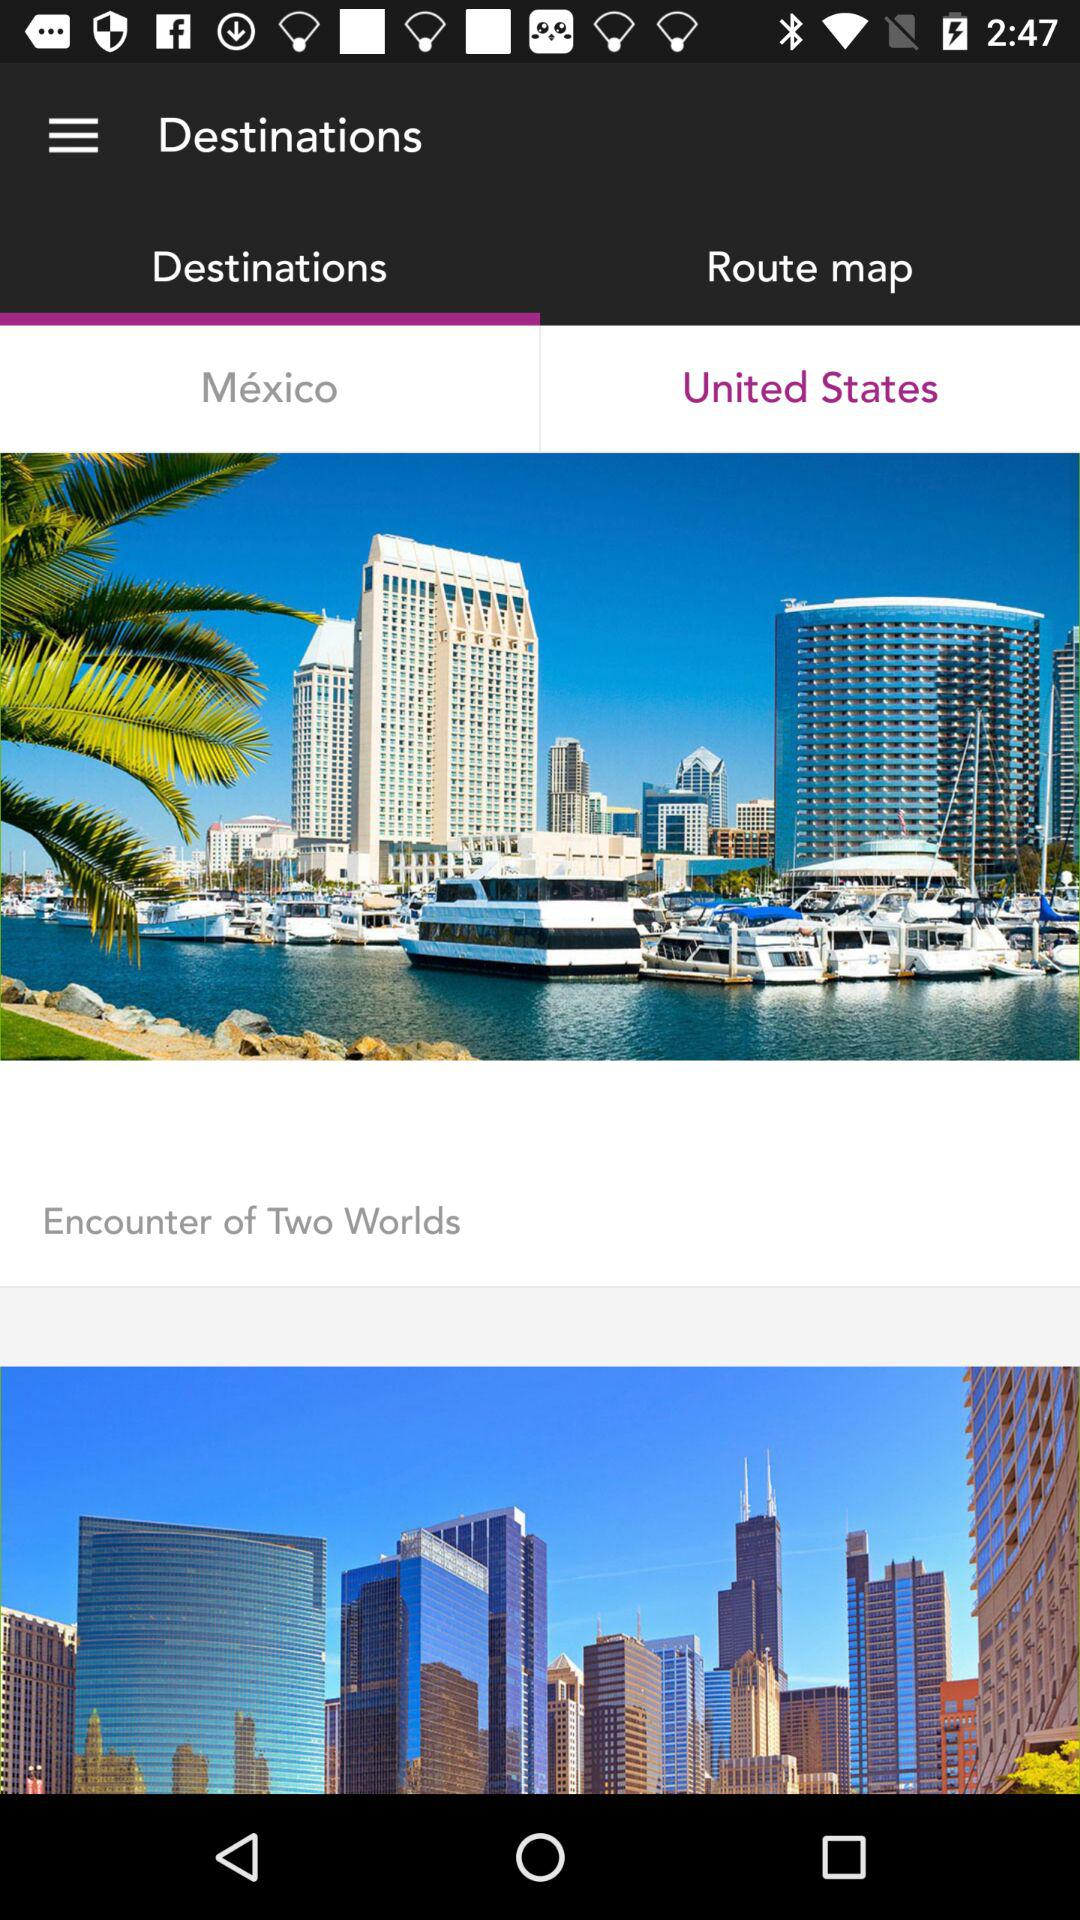What is the selected option in "Destinations"? The selected option is "United States". 